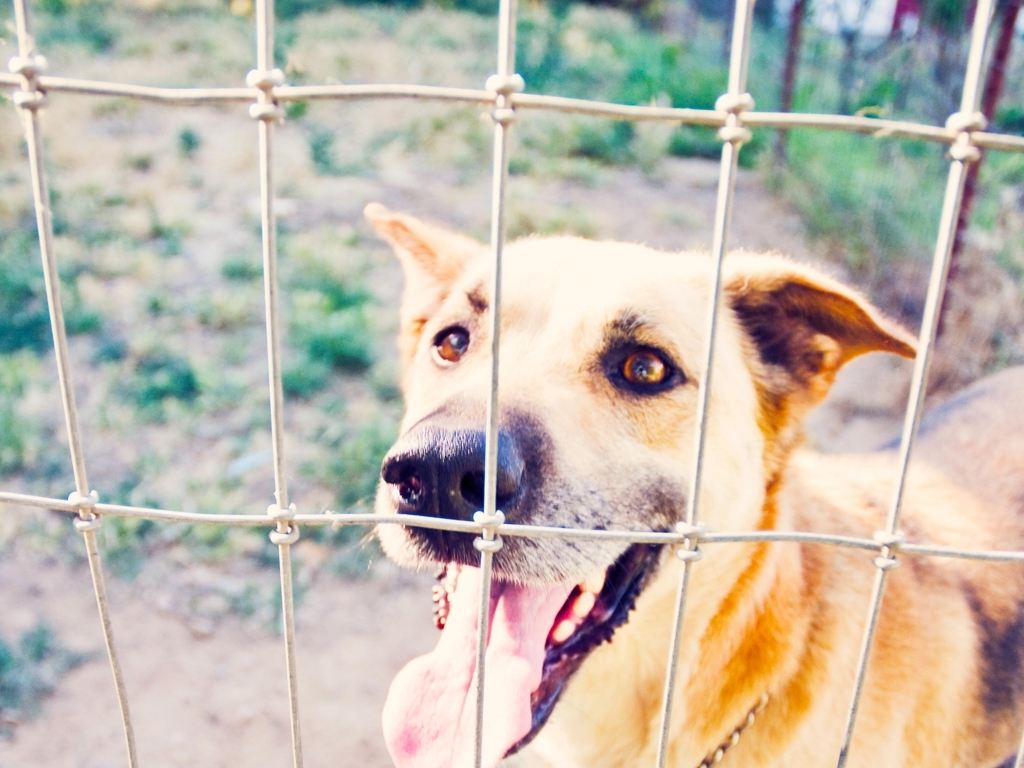Is the clarity of the photo acceptable?
A. Yes
B. No
Answer with the option's letter from the given choices directly.
 A. 